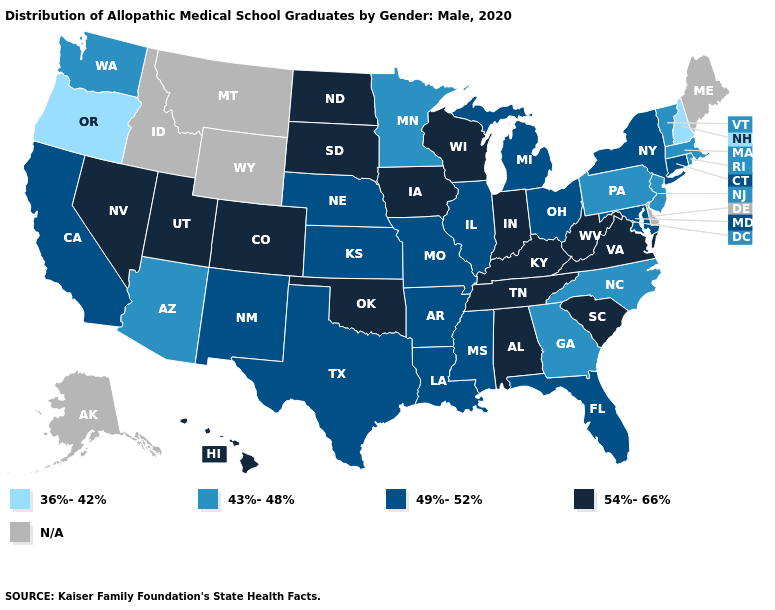What is the highest value in states that border New Jersey?
Give a very brief answer. 49%-52%. What is the value of Georgia?
Answer briefly. 43%-48%. What is the highest value in the USA?
Keep it brief. 54%-66%. What is the value of Pennsylvania?
Quick response, please. 43%-48%. What is the lowest value in states that border Tennessee?
Quick response, please. 43%-48%. What is the lowest value in the USA?
Quick response, please. 36%-42%. Name the states that have a value in the range 54%-66%?
Short answer required. Alabama, Colorado, Hawaii, Indiana, Iowa, Kentucky, Nevada, North Dakota, Oklahoma, South Carolina, South Dakota, Tennessee, Utah, Virginia, West Virginia, Wisconsin. Which states hav the highest value in the West?
Short answer required. Colorado, Hawaii, Nevada, Utah. What is the value of Wyoming?
Give a very brief answer. N/A. What is the highest value in states that border Vermont?
Quick response, please. 49%-52%. What is the value of Connecticut?
Short answer required. 49%-52%. Name the states that have a value in the range 43%-48%?
Give a very brief answer. Arizona, Georgia, Massachusetts, Minnesota, New Jersey, North Carolina, Pennsylvania, Rhode Island, Vermont, Washington. What is the value of Mississippi?
Concise answer only. 49%-52%. Does New Hampshire have the highest value in the USA?
Write a very short answer. No. 